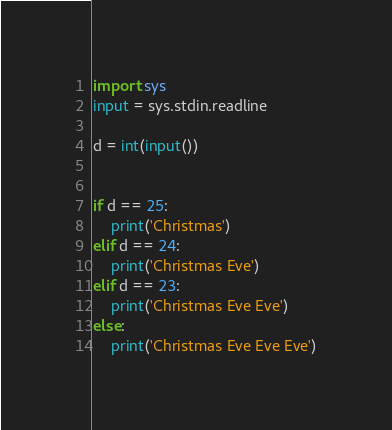Convert code to text. <code><loc_0><loc_0><loc_500><loc_500><_Python_>import sys
input = sys.stdin.readline

d = int(input())


if d == 25:
    print('Christmas')
elif d == 24:
    print('Christmas Eve')
elif d == 23:
    print('Christmas Eve Eve')
else:
    print('Christmas Eve Eve Eve')</code> 